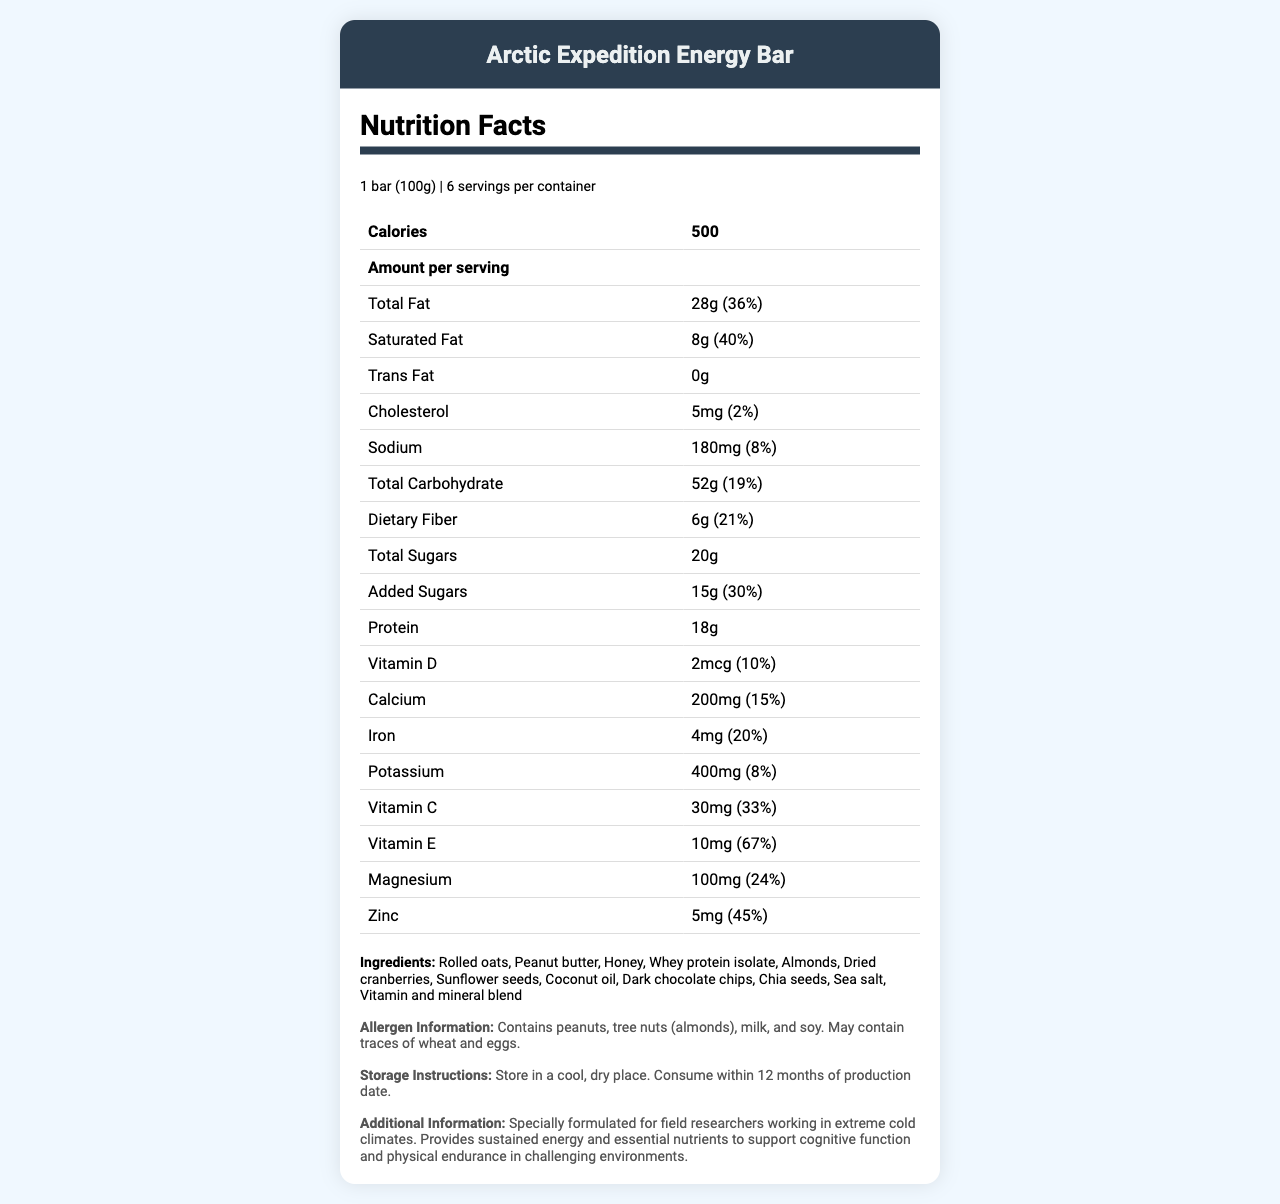what is the serving size of the Arctic Expedition Energy Bar? The serving size information is clearly stated at the beginning of the document as "1 bar (100g)".
Answer: 1 bar (100g) how many servings are there per container? The document mentions that there are 6 servings per container.
Answer: 6 how much protein is in one serving of the energy bar? The protein content per serving is listed as 18g in the document.
Answer: 18g what is the daily value percentage of saturated fat? The document indicates that the daily value percentage for saturated fat is 40%.
Answer: 40% does the energy bar contain any trans fat? The document explicitly states that the energy bar contains 0g of trans fat.
Answer: No how much vitamin C does one serving provide? The amount of vitamin C per serving is specified as 30mg.
Answer: 30mg which of the following ingredients is *not* listed in the energy bar? A. Peanut Butter B. Rolled Oats C. Almond Butter D. Dark Chocolate Chips E. Honey The ingredients list includes peanut butter, rolled oats, dark chocolate chips, and honey, but not almond butter.
Answer: C what is the percentage of daily value for zinc in one serving? The document states that one serving of the energy bar provides 45% of the daily value for zinc.
Answer: 45% what is the main allergen information provided? The allergen information is clearly listed in a dedicated section.
Answer: Contains peanuts, tree nuts (almonds), milk, and soy. May contain traces of wheat and eggs. how should the energy bars be stored? The storage instructions are provided to ensure proper maintenance and shelf life of the energy bars.
Answer: Store in a cool, dry place. Consume within 12 months of production date. what is the total fat content per serving? The document states that the total fat content per serving is 28g.
Answer: 28g what is the manufacturer's name? The manufacturer of the energy bar is identified as "Global Weather Monitoring Nutrition Labs".
Answer: Global Weather Monitoring Nutrition Labs what is the fiber content per serving? According to the document, each serving contains 6g of dietary fiber.
Answer: 6g is the energy bar specifically formulated for field researchers in extreme cold climates? The document mentions that the energy bar is specially formulated for field researchers working in extreme cold climates.
Answer: Yes summarize the main idea of the document. The document provides a comprehensive overview of the "Arctic Expedition Energy Bar," highlighting its nutritional benefits and suitability for field researchers in harsh conditions.
Answer: The document presents the nutrition facts of the "Arctic Expedition Energy Bar," detailing its serving size, nutritional content, ingredients, allergen information, storage instructions, and formulation purpose. 